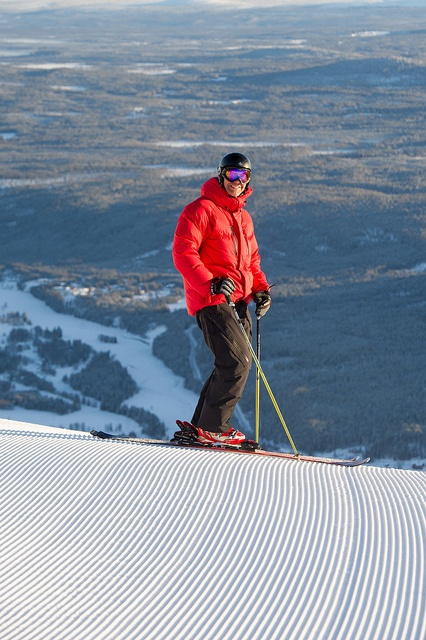Describe the objects in this image and their specific colors. I can see people in lightgray, black, red, brown, and salmon tones and skis in lightgray, gray, darkgray, and blue tones in this image. 